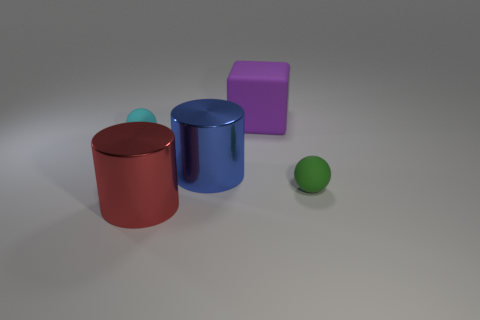What sort of environment do these objects suggest they are in? These objects give the impression of being in an artificial or controlled environment, such as a studio setup for a photo shoot or a computer-generated simulation, due to the uniform lighting and absence of any natural elements or context. 